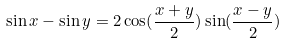<formula> <loc_0><loc_0><loc_500><loc_500>\sin x - \sin y = 2 \cos ( \frac { x + y } { 2 } ) \sin ( \frac { x - y } { 2 } )</formula> 